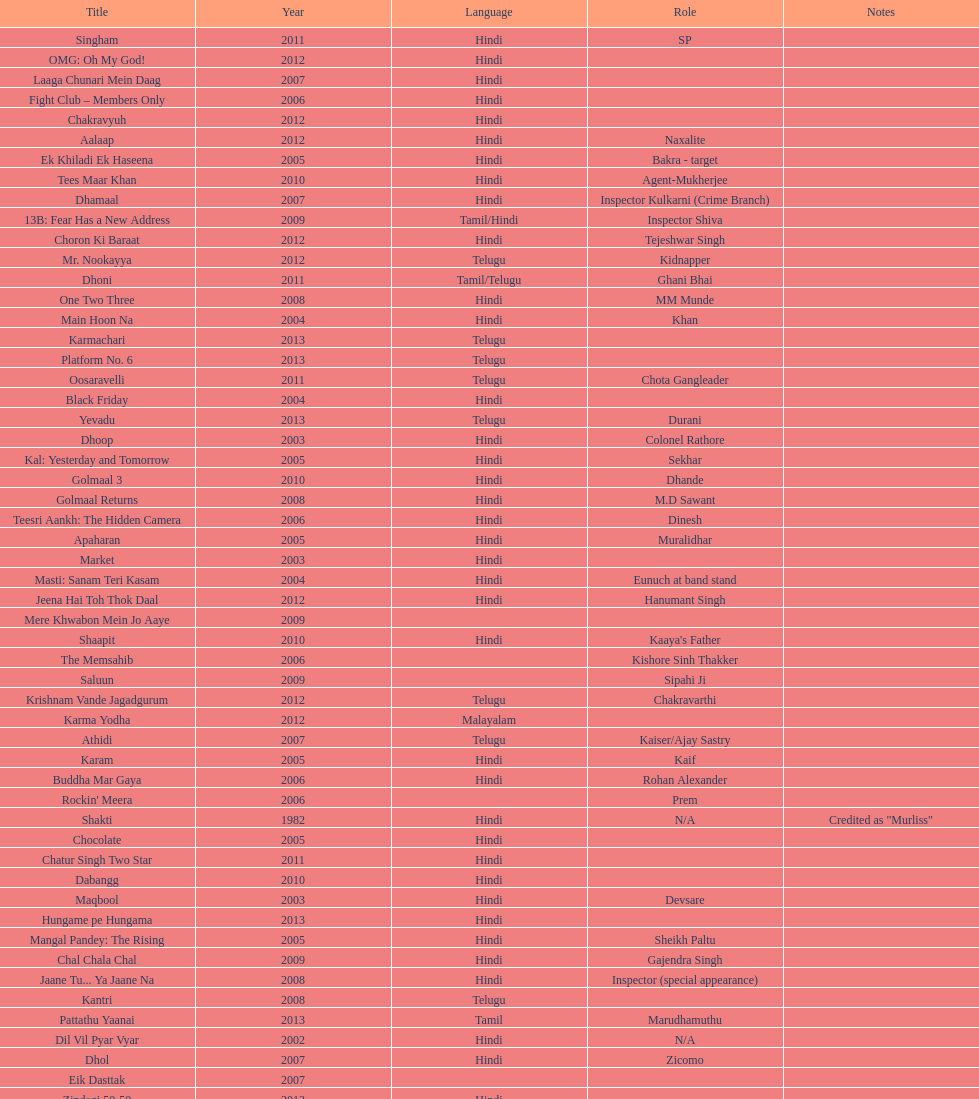What is the first language after hindi Telugu. 